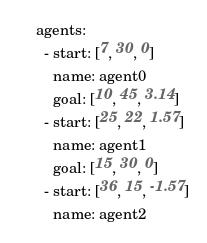Convert code to text. <code><loc_0><loc_0><loc_500><loc_500><_YAML_>agents:
  - start: [7, 30, 0]
    name: agent0
    goal: [10, 45, 3.14]
  - start: [25, 22, 1.57]
    name: agent1
    goal: [15, 30, 0]
  - start: [36, 15, -1.57]
    name: agent2</code> 